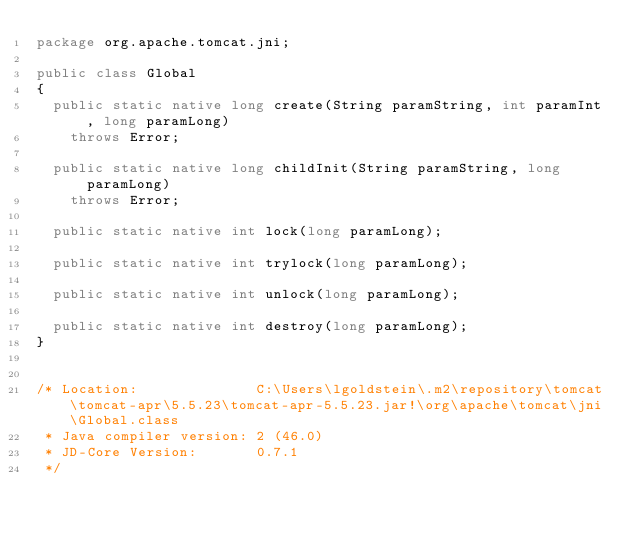Convert code to text. <code><loc_0><loc_0><loc_500><loc_500><_Java_>package org.apache.tomcat.jni;

public class Global
{
  public static native long create(String paramString, int paramInt, long paramLong)
    throws Error;
  
  public static native long childInit(String paramString, long paramLong)
    throws Error;
  
  public static native int lock(long paramLong);
  
  public static native int trylock(long paramLong);
  
  public static native int unlock(long paramLong);
  
  public static native int destroy(long paramLong);
}


/* Location:              C:\Users\lgoldstein\.m2\repository\tomcat\tomcat-apr\5.5.23\tomcat-apr-5.5.23.jar!\org\apache\tomcat\jni\Global.class
 * Java compiler version: 2 (46.0)
 * JD-Core Version:       0.7.1
 */</code> 